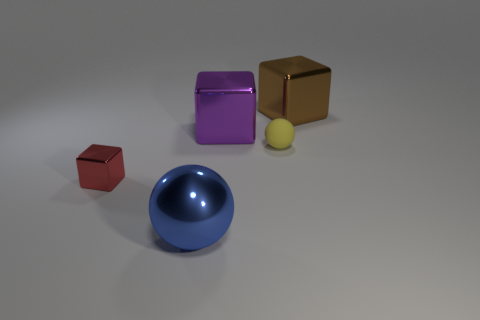How does the size of the red cube compare to the other objects? The red cube is the smallest object among the group. Its dimensions are less than those of the other cube, and it is noticeably smaller compared to the large sphere and the medium-sized cylinder, emphasizing an intriguing play of scale within the scene. 